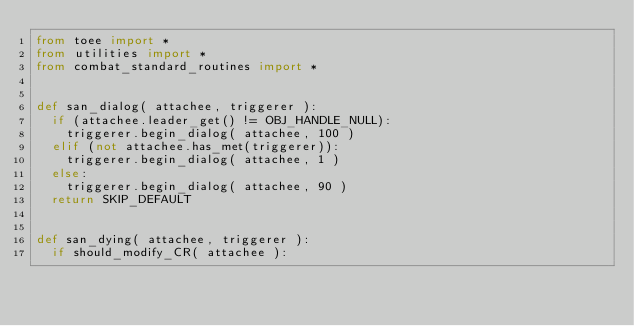Convert code to text. <code><loc_0><loc_0><loc_500><loc_500><_Python_>from toee import *
from utilities import *
from combat_standard_routines import *


def san_dialog( attachee, triggerer ):
	if (attachee.leader_get() != OBJ_HANDLE_NULL):
		triggerer.begin_dialog( attachee, 100 )
	elif (not attachee.has_met(triggerer)):
		triggerer.begin_dialog( attachee, 1 )
	else:
		triggerer.begin_dialog( attachee, 90 )
	return SKIP_DEFAULT


def san_dying( attachee, triggerer ):
	if should_modify_CR( attachee ):</code> 